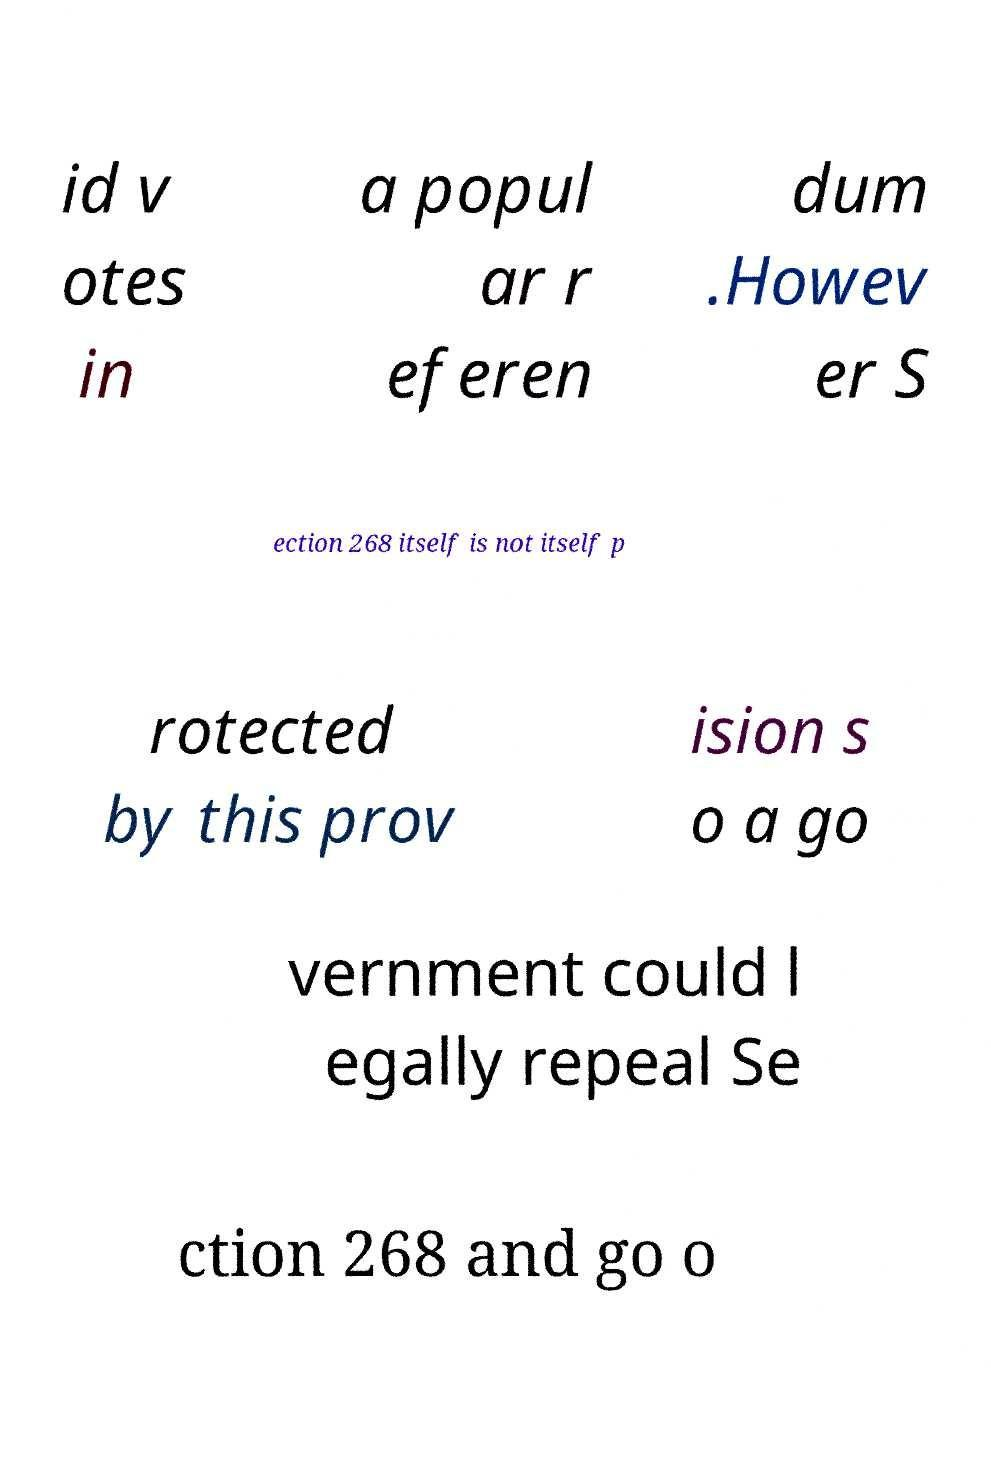I need the written content from this picture converted into text. Can you do that? id v otes in a popul ar r eferen dum .Howev er S ection 268 itself is not itself p rotected by this prov ision s o a go vernment could l egally repeal Se ction 268 and go o 